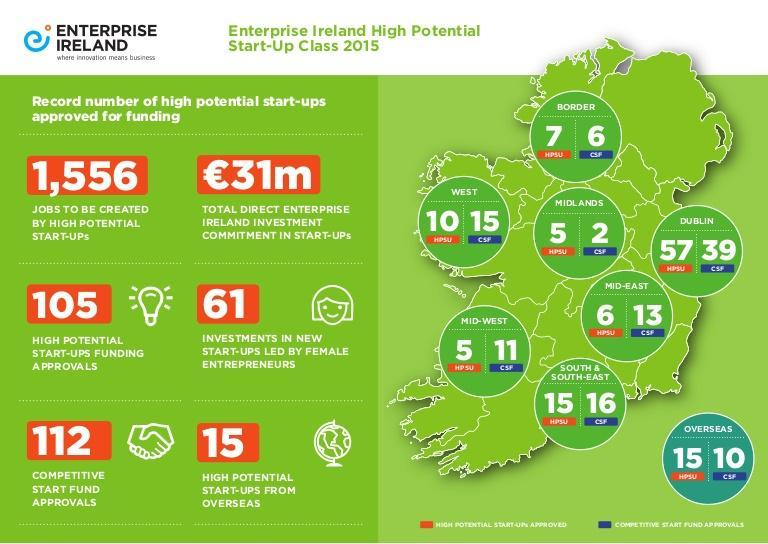What number of investments in new start-ups were led by female entrepreneurs in Ireland in 2015?
Answer the question with a short phrase. 61 What is the number of jobs to be created by the high potential start-ups in Ireland? 1,556 How many competitive start fund approvals are from overseas in Ireland in 2015? 10 What is the total direct enterprise investment of Ireland (in euros) in start-ups in 2015? 31m How many high potential start-ups were approved for funding in Ireland in 2015? 105 How many competitive start-ups were approved for funding in Dublin city of Ireland in 2015? 39 How many competitive start fund approvals were done in Ireland in 2015? 112 How many high potential start-ups were approved for funding in Midland region of Ireland in 2015? 5 How many high potential startups are from overseas in Ireland in 2015? 15 